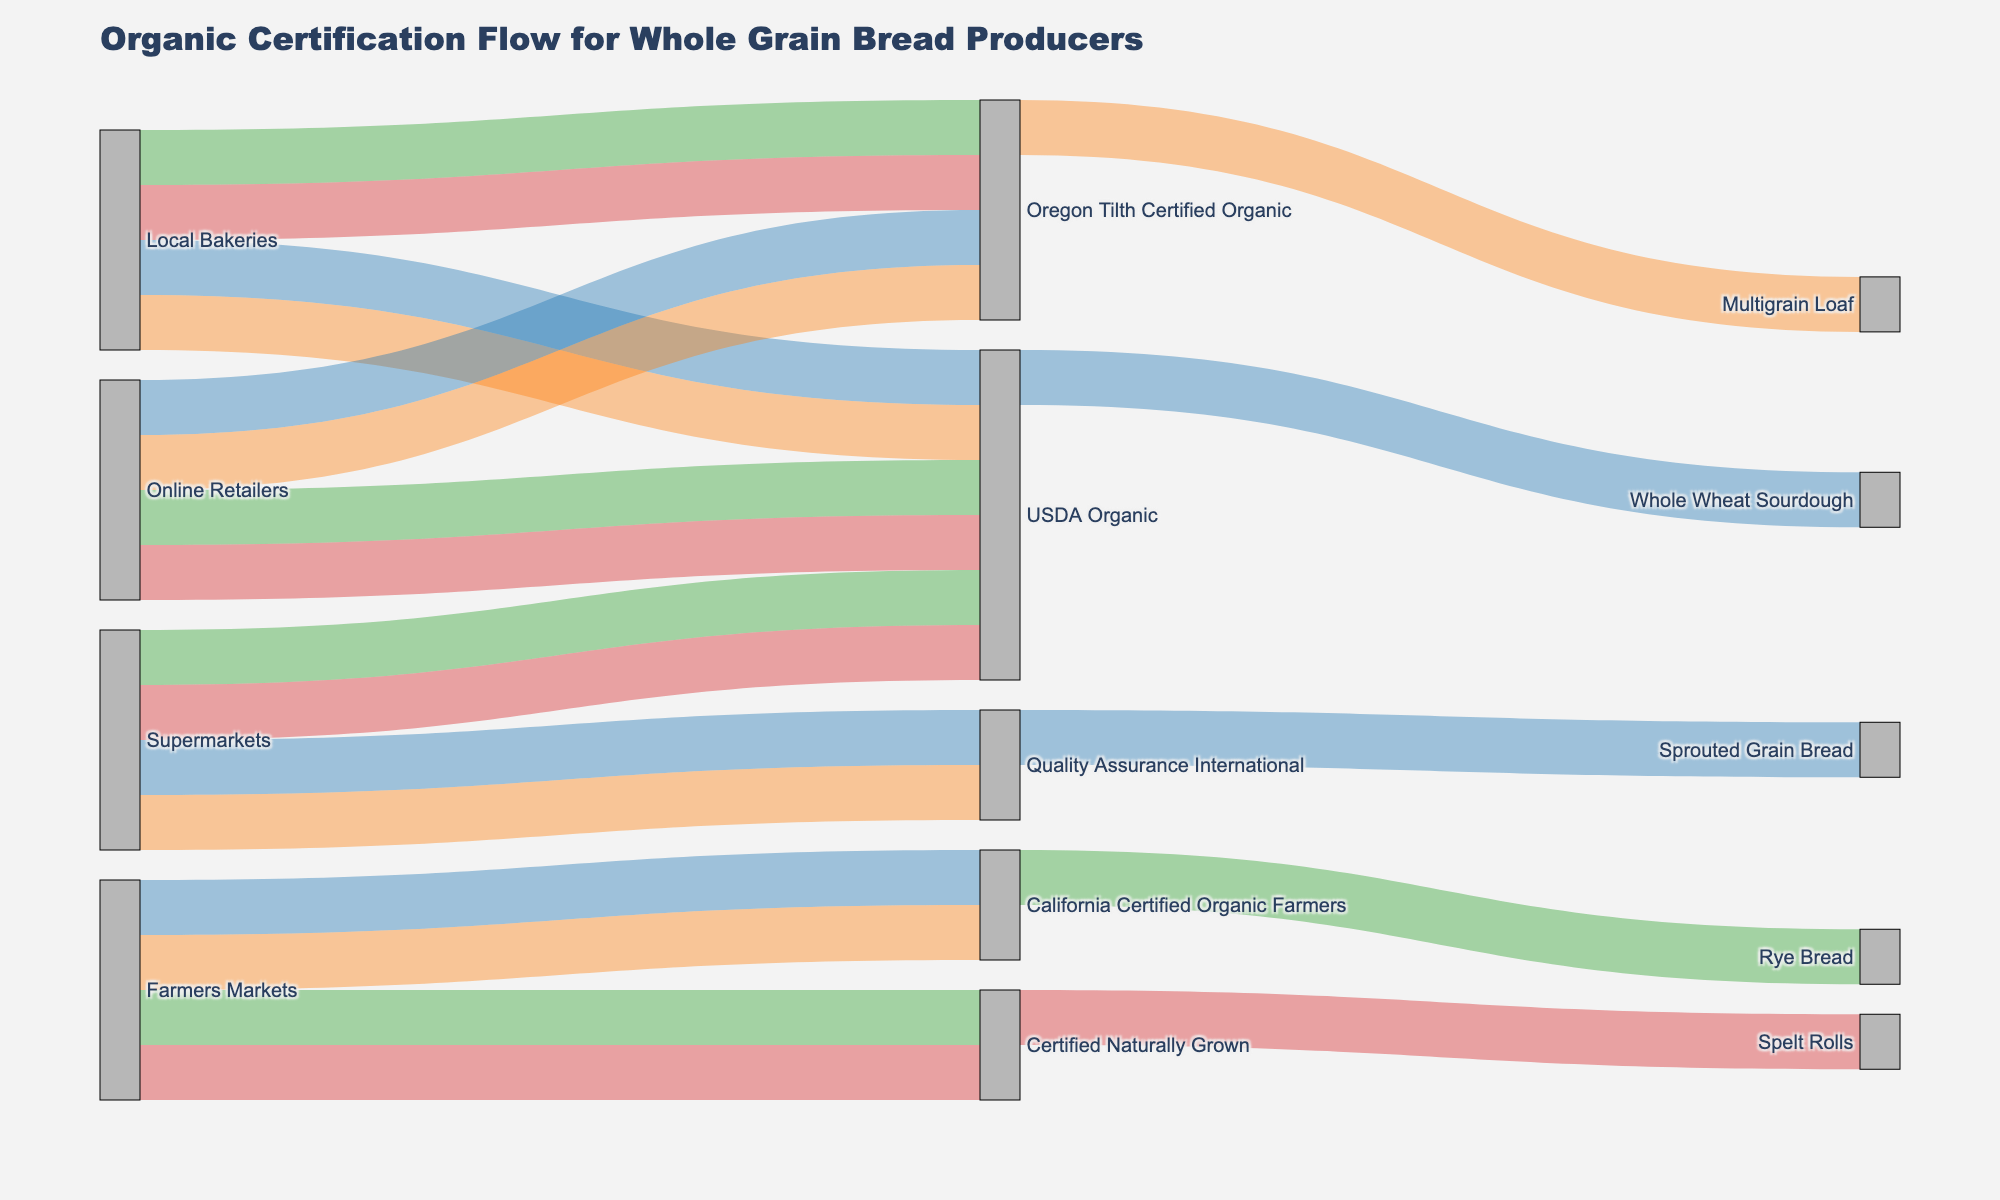what is the title of the diagram? The title is located at the top of the diagram and provides an overview of the content. In this case, the title reads "Organic Certification Flow for Whole Grain Bread Producers."
Answer: Organic Certification Flow for Whole Grain Bread Producers how many certification types are shown in the diagram? You can identify certification types by looking at the labels between the initial sources and the final products. In this Sankey diagram, there are four distinct certification types.
Answer: Four which source has the most unique products? To determine this, count the number of different products linked to each source. Farmers Markets have four unique products, more than Local Bakeries, Supermarkets, and Online Retailers which each have three.
Answer: Farmers Markets what is the most common certification type for products sourced from supermarkets? Follow the links from the source "Supermarkets" to the certification types. Supermarkets are linked to USDA Organic the most frequently out of all the certifications.
Answer: USDA Organic how many products are certified by Oregon Tilth Certified Organic? Count the number of products connected to the "Oregon Tilth Certified Organic" node. There are four such products: Rye Bread, Spelt Rolls, Kamut Bread, and Amaranth Rolls.
Answer: Four which product categories are linked to the certification type "Certified Naturally Grown"? Check the links coming from the "Certified Naturally Grown" node and note the end nodes. Certified Naturally Grown is linked to Oat and Honey Bread and Flaxseed Loaf.
Answer: Oat and Honey Bread, Flaxseed Loaf which certification type links to only one product from local bakeries? Identify the certification types connected to products from Local Bakeries and note the ones with exactly one link. Oregon Tilth Certified Organic is the only certification linking to one product, which is Rye Bread.
Answer: Oregon Tilth Certified Organic are there any certification types that appear to have an equal number of products across different sources? Compare the count of products linked to each certification type across the sources. USDA Organic appears across Local Bakeries, Supermarkets, and Online Retailers, each with two products.
Answer: USDA Organic which two sources contribute equally to products certified by California Certified Organic Farmers? Trace the connections from "California Certified Organic Farmers" to the initial sources. Both Farmers Markets and no other source contribute two products certified by California Certified Organic Farmers.
Answer: Farmers Markets what is the ratio of local bakery products to supermarket products? Count the total products from Local Bakeries and Supermarkets. Local Bakeries have four products while Supermarkets have four. The ratio of Local Bakery products to Supermarket products is 3:1.
Answer: 3:4 